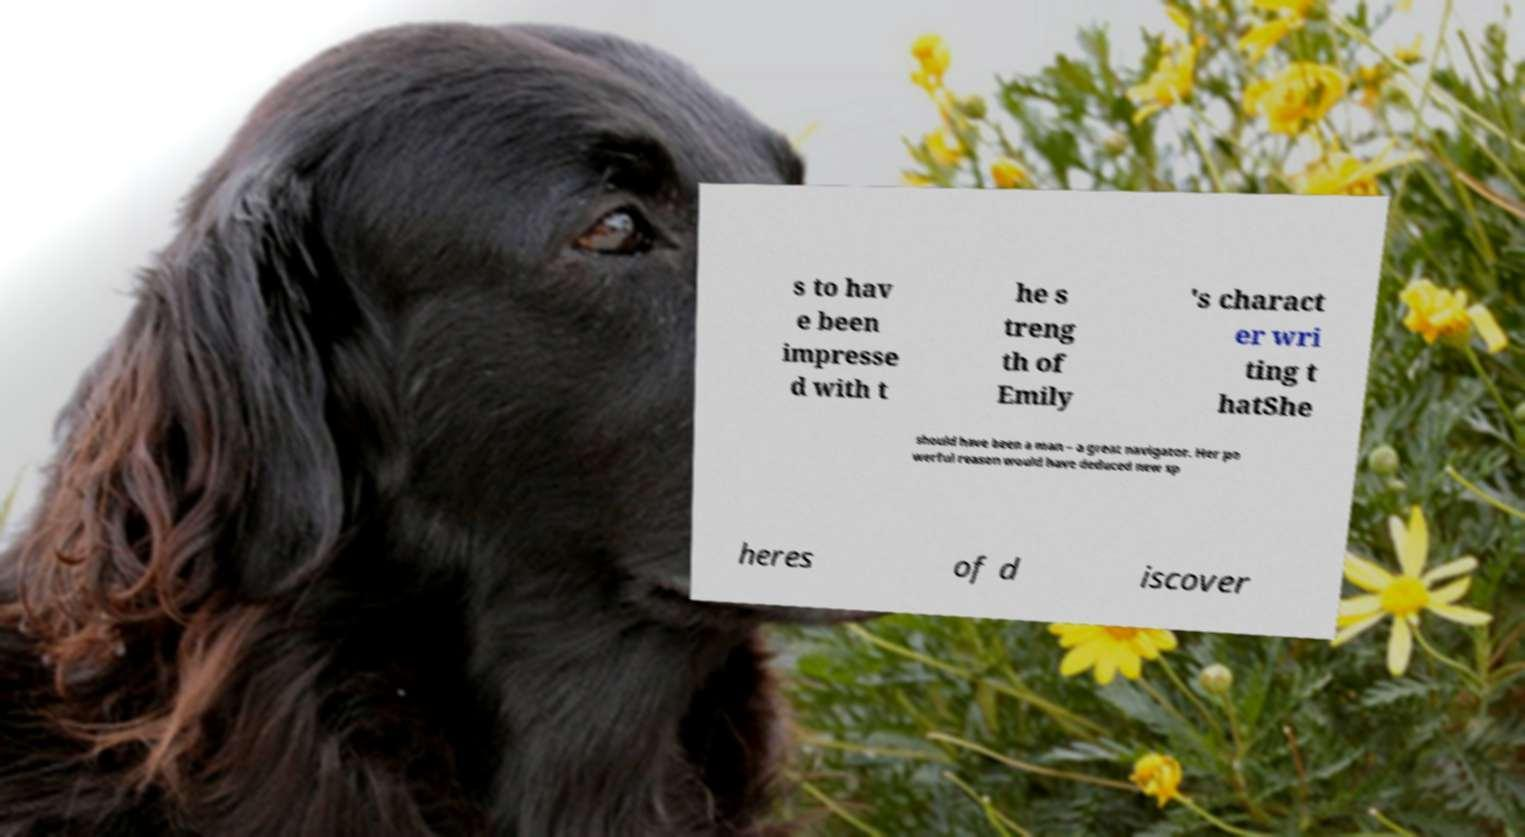Could you extract and type out the text from this image? s to hav e been impresse d with t he s treng th of Emily 's charact er wri ting t hatShe should have been a man – a great navigator. Her po werful reason would have deduced new sp heres of d iscover 